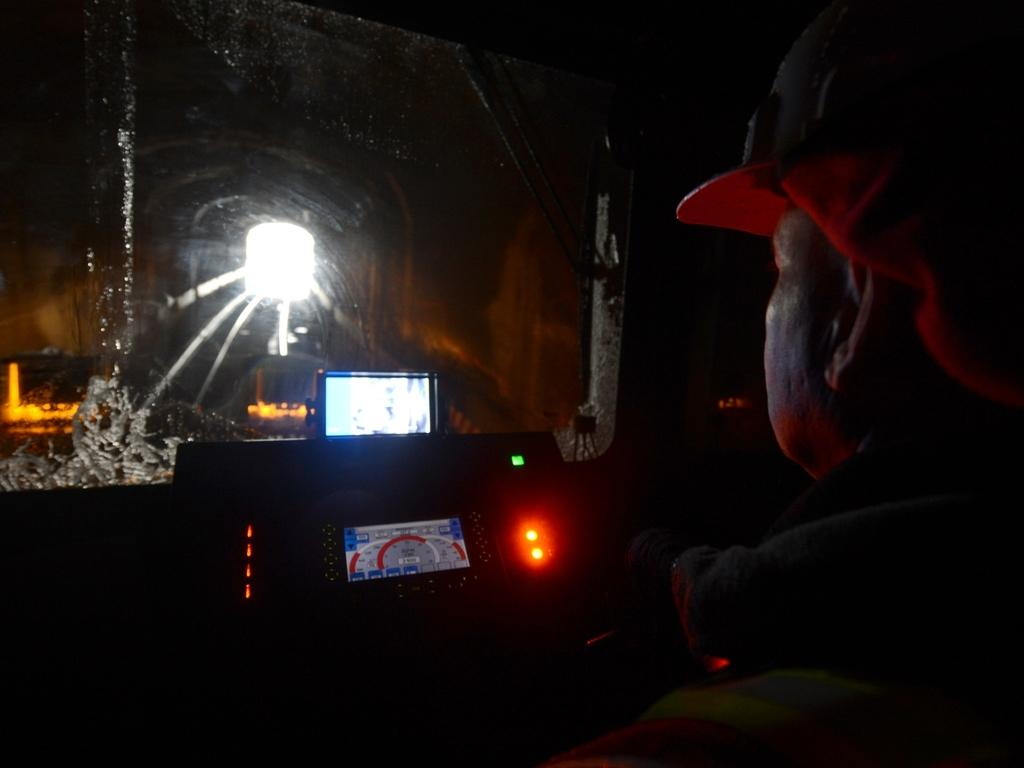What type of location is depicted in the image? The image is an inner view of a vehicle. Who or what can be seen inside the vehicle? There is a person sitting in the vehicle. What type of technology is present in the vehicle? There are screens visible in the vehicle. What material is used for the windows in the vehicle? There is glass in the vehicle. Can you describe the lighting conditions inside the vehicle? There is light visible in the vehicle. What can be seen outside the vehicle through the glass? There are objects visible through the glass. What type of poison is being used to protest against the driver in the image? There is no protest or poison present in the image; it is an inner view of a vehicle with a person sitting inside. 